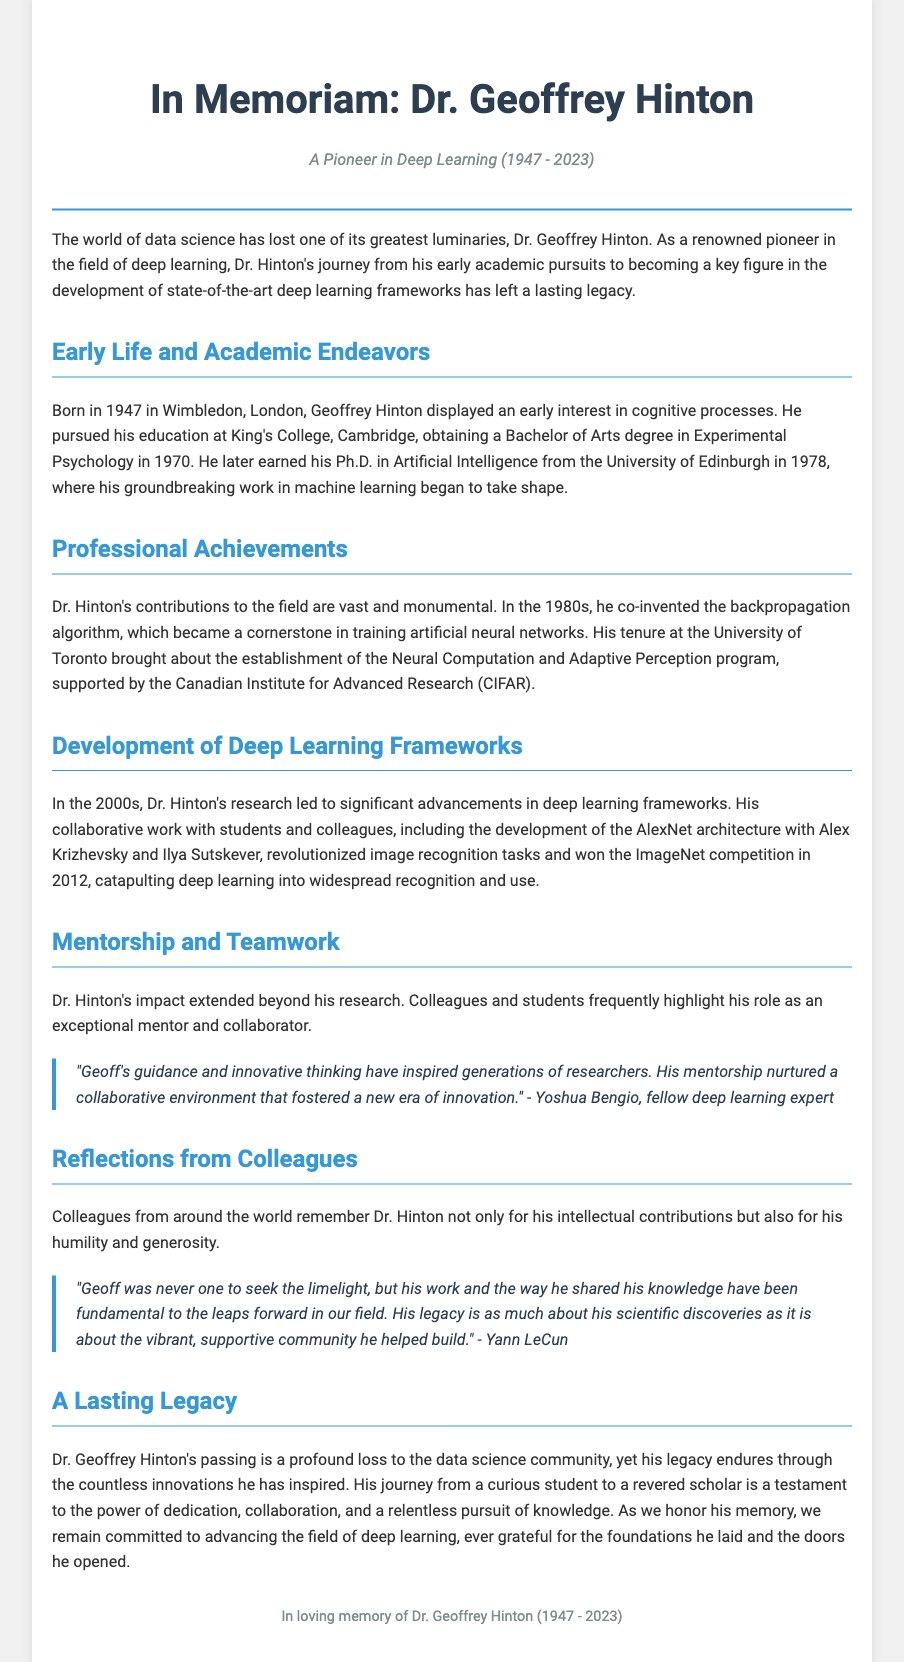What year was Dr. Geoffrey Hinton born? The document states that Dr. Geoffrey Hinton was born in 1947.
Answer: 1947 What algorithm did Dr. Hinton co-invent in the 1980s? The document mentions that he co-invented the backpropagation algorithm.
Answer: backpropagation Which university did Dr. Hinton earn his Ph.D. from? The document specifies that he earned his Ph.D. from the University of Edinburgh.
Answer: University of Edinburgh What architecture did Dr. Hinton help develop with Alex Krizhevsky and Ilya Sutskever? The document refers to the AlexNet architecture.
Answer: AlexNet Who highlighted Dr. Hinton's role as an exceptional mentor? The document cites Yoshua Bengio as highlighting Dr. Hinton's mentorship.
Answer: Yoshua Bengio In what year did Dr. Hinton win the ImageNet competition? The document mentions that this win occurred in 2012.
Answer: 2012 What was a key aspect of Dr. Hinton's legacy mentioned in the document? The document discusses his impact on fostering a collaborative environment for innovation.
Answer: collaborative environment How long did Dr. Hinton's life span according to the obituary? The document states he lived from 1947 to 2023, which sums up to 76 years.
Answer: 76 years What is the subtitle of the obituary? The document lists the subtitle as "A Pioneer in Deep Learning".
Answer: A Pioneer in Deep Learning 